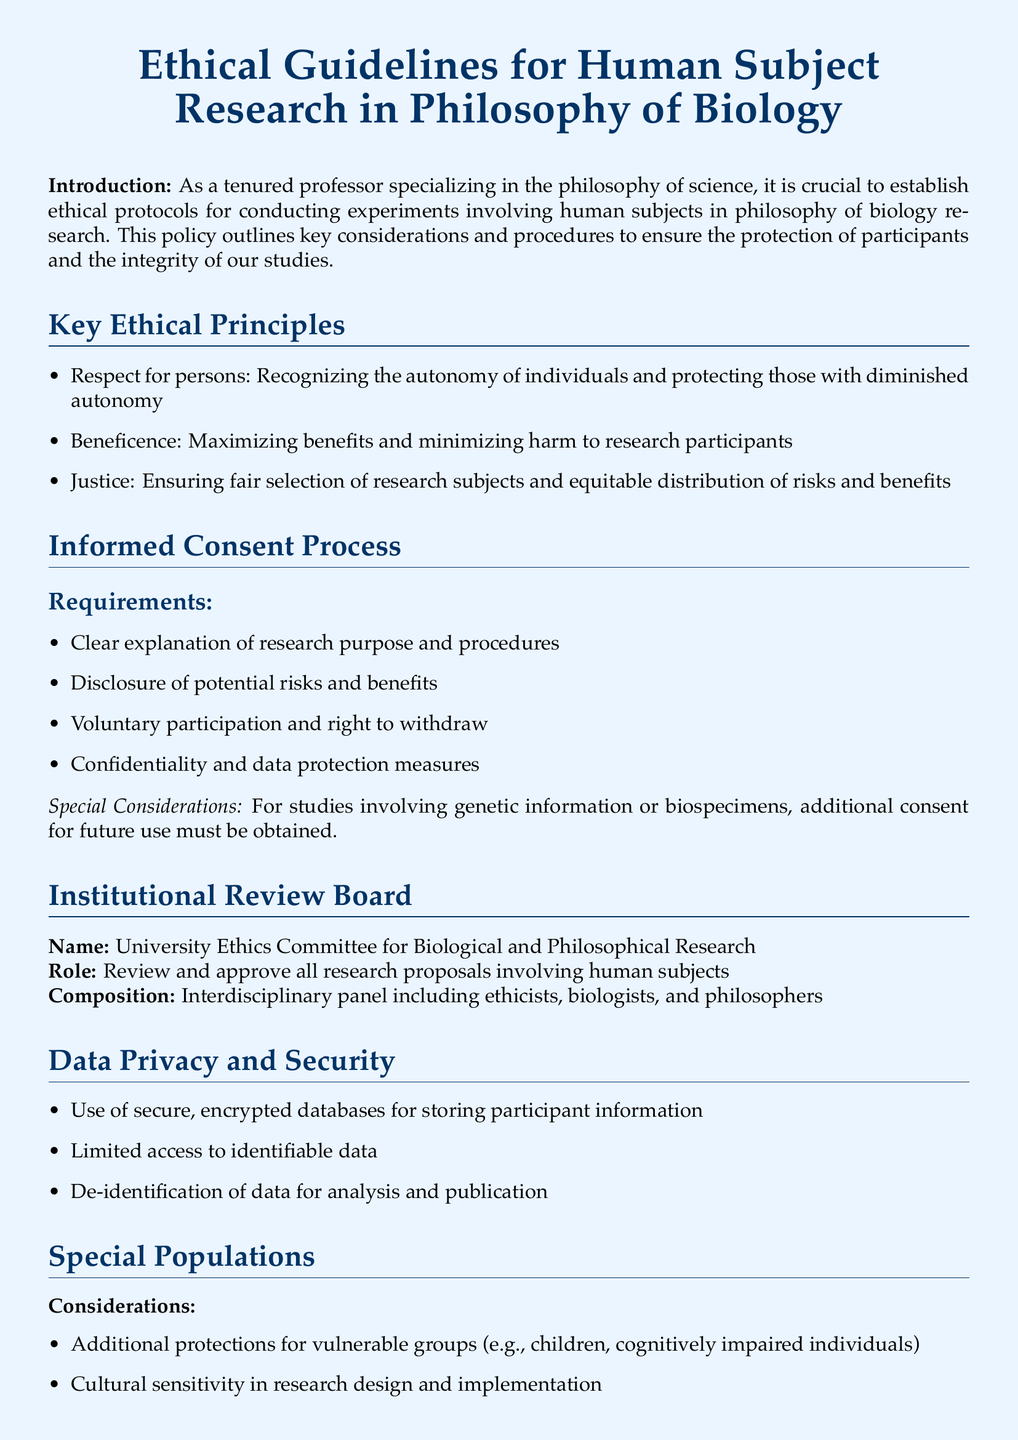What is the name of the review board? The review board is tasked with overseeing research involving human subjects and is named in the document.
Answer: University Ethics Committee for Biological and Philosophical Research What are the three key ethical principles? The document lists three ethical principles that guide research, which are stated explicitly.
Answer: Respect for persons, Beneficence, Justice What is required for informed consent? The document outlines several requirements for obtaining informed consent, providing a clear list.
Answer: Clear explanation of research purpose and procedures, Disclosure of potential risks and benefits, Voluntary participation and right to withdraw, Confidentiality and data protection measures Which program must all researchers complete? The document specifies a training program that researchers are required to complete to ensure ethical research practices.
Answer: Collaborative Institutional Training Initiative (CITI) Program on Human Subjects Research What type of database should be used for participant information? The document advises on the method of storing sensitive participant information that prioritizes security.
Answer: Secure, encrypted databases What additional protections are mentioned for vulnerable groups? The document highlights specific considerations needed when researching certain populations, informing the reader of best practices.
Answer: Additional protections for vulnerable groups (e.g., children, cognitively impaired individuals) 